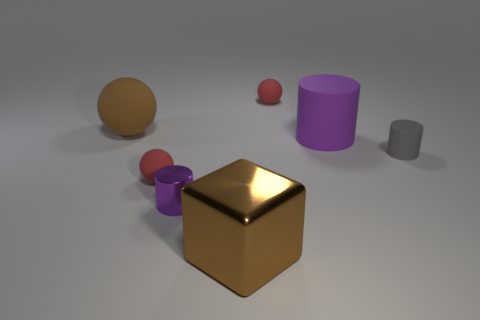Add 2 tiny gray matte objects. How many objects exist? 9 Subtract all cylinders. How many objects are left? 4 Subtract 0 purple cubes. How many objects are left? 7 Subtract all tiny rubber balls. Subtract all cylinders. How many objects are left? 2 Add 7 tiny balls. How many tiny balls are left? 9 Add 6 large metallic cubes. How many large metallic cubes exist? 7 